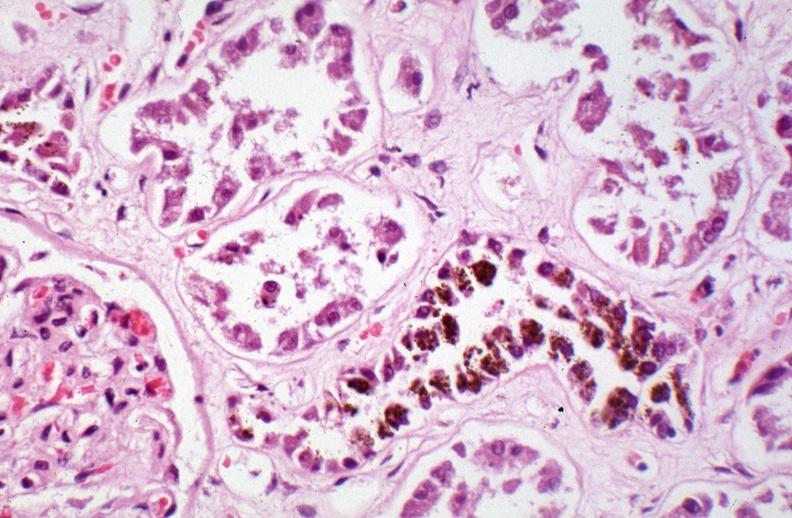what does this image show?
Answer the question using a single word or phrase. Kidney 